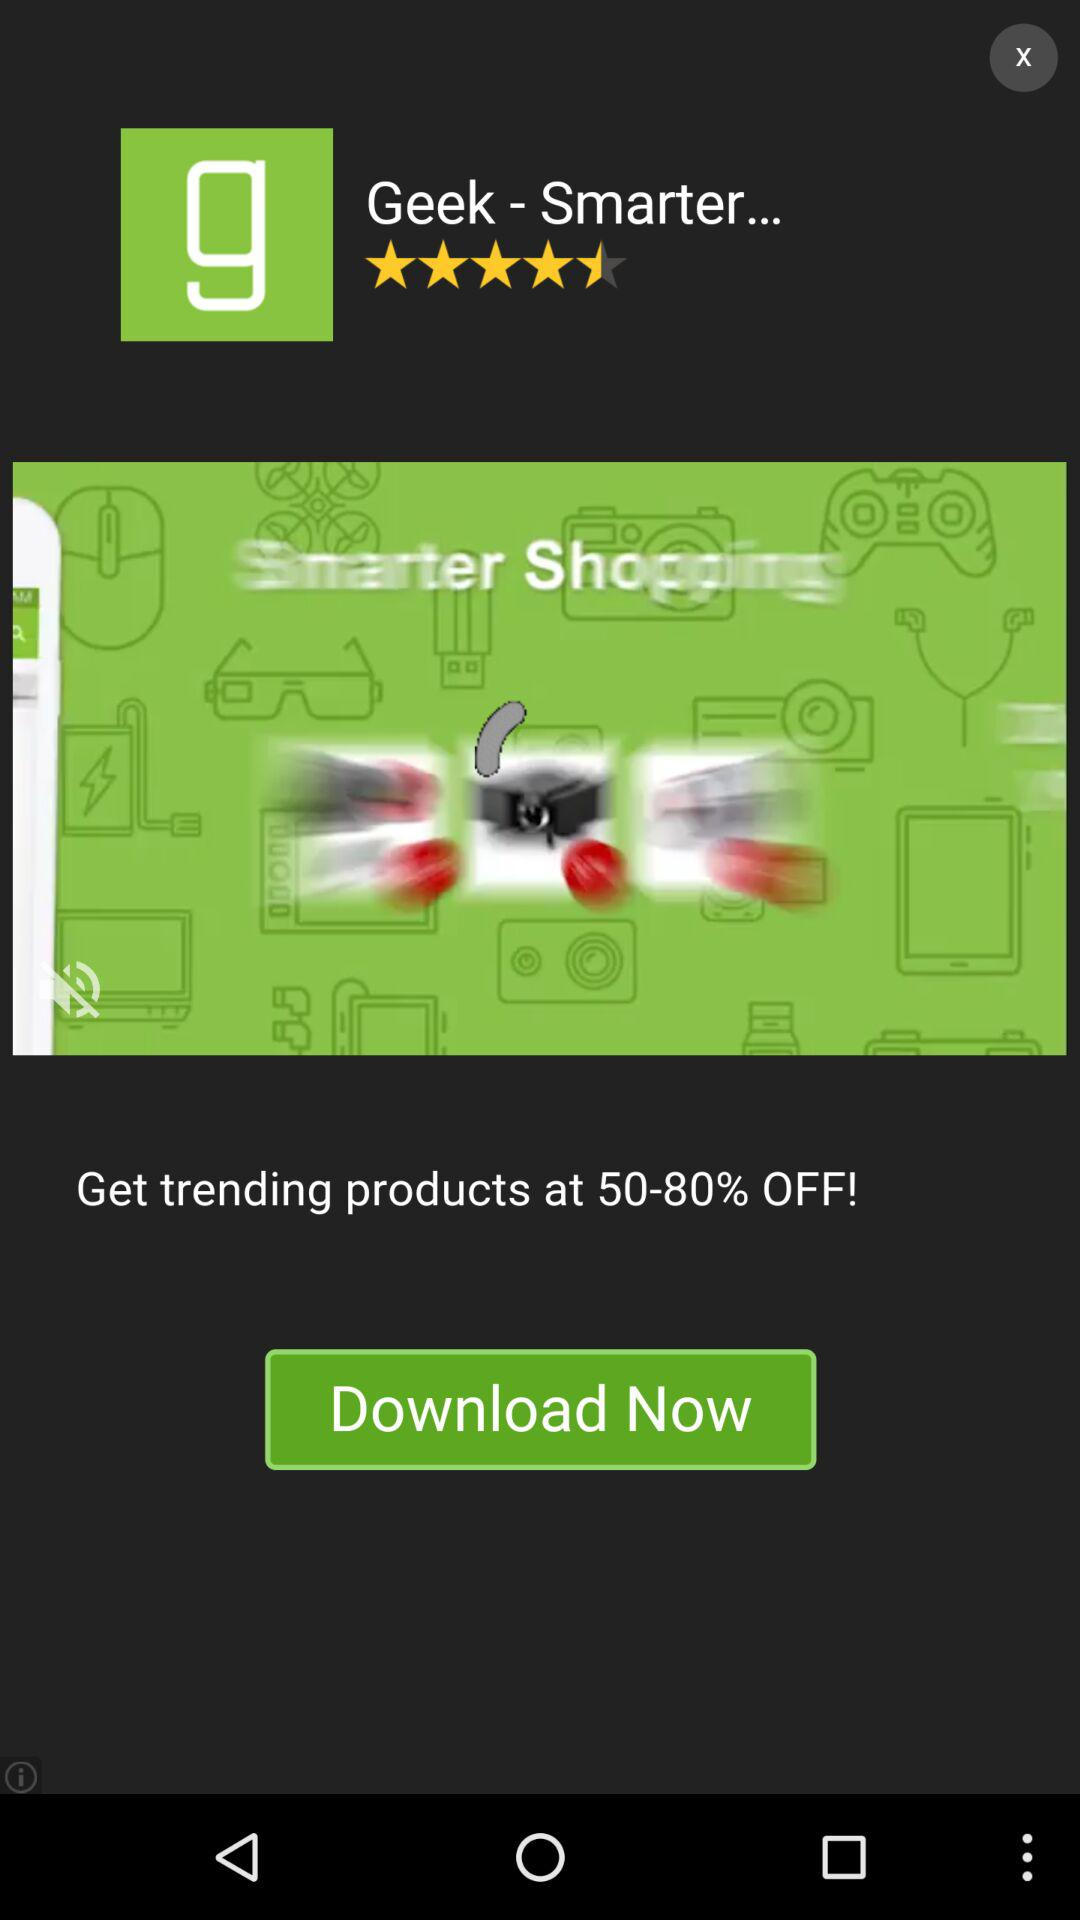How many percent off are the trending products?
Answer the question using a single word or phrase. 50-80% 